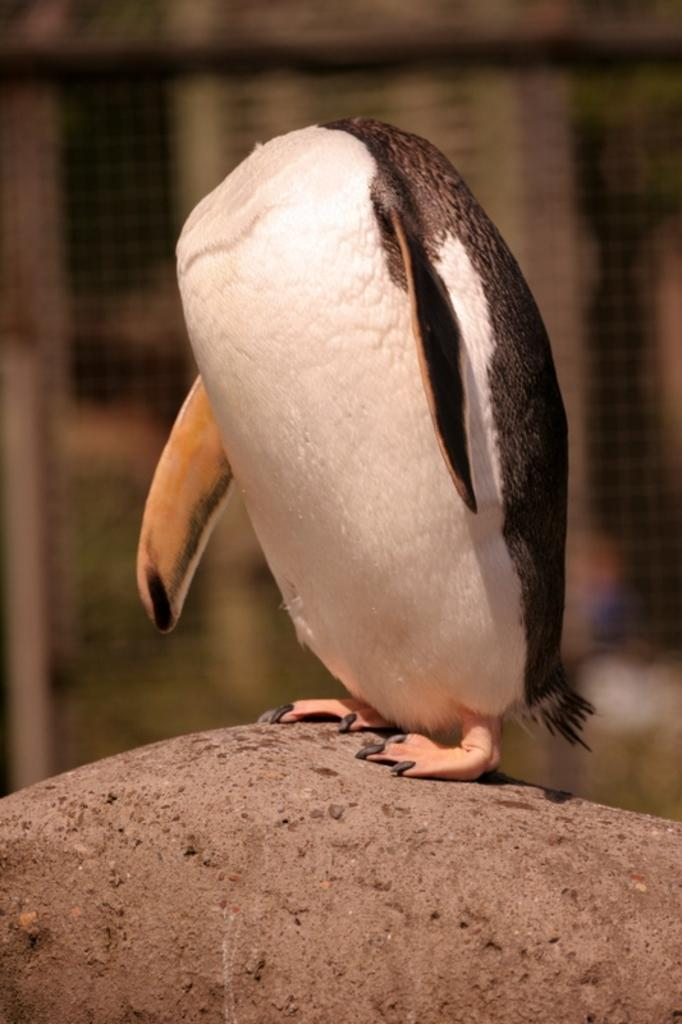What animal is present in the image? There is a penguin in the image. What is the penguin standing on? The penguin is standing on a rock. What type of structure can be seen in the image? There is a fence visible in the image. What type of loaf is the penguin holding in the image? There is no loaf present in the image; it features a penguin standing on a rock with a fence visible. What kind of form does the penguin's haircut have in the image? Penguins do not have haircuts, and there is no form mentioned in the image. 